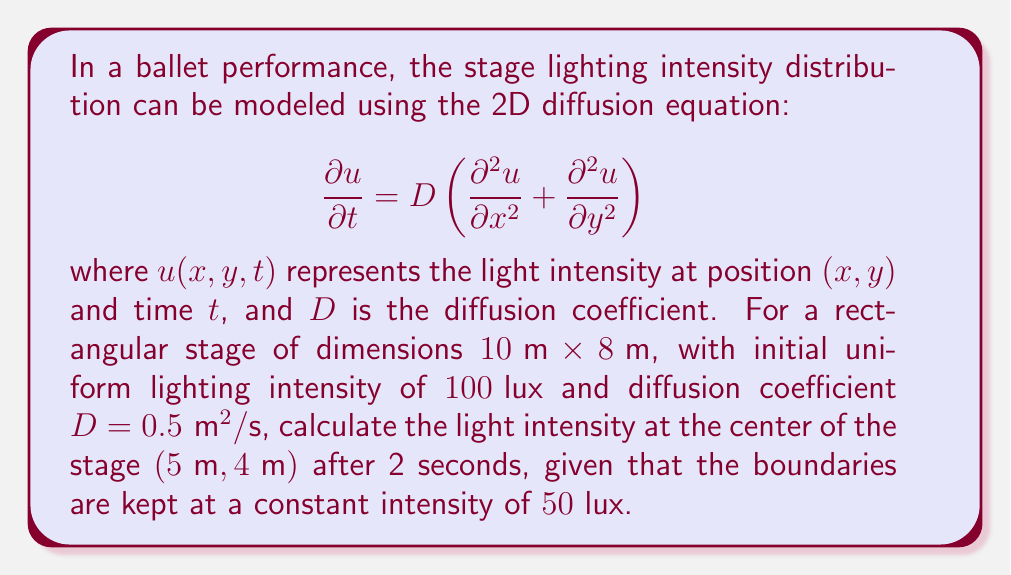Provide a solution to this math problem. To solve this problem, we need to use the analytical solution for the 2D diffusion equation with Dirichlet boundary conditions. The solution can be expressed as a double Fourier series:

$$u(x,y,t) = u_{\infty} + \sum_{m=1}^{\infty}\sum_{n=1}^{\infty} A_{mn} \sin\left(\frac{m\pi x}{L_x}\right)\sin\left(\frac{n\pi y}{L_y}\right)e^{-\lambda_{mn}t}$$

where:
- $u_{\infty}$ is the steady-state solution (boundary condition)
- $L_x = 10\text{ m}$ and $L_y = 8\text{ m}$ are the stage dimensions
- $\lambda_{mn} = D\pi^2\left(\frac{m^2}{L_x^2} + \frac{n^2}{L_y^2}\right)$
- $A_{mn}$ are the Fourier coefficients

For our initial condition $u_0(x,y) = 100\text{ lux}$ and boundary condition $u_{\infty} = 50\text{ lux}$, we can calculate $A_{mn}$:

$$A_{mn} = \frac{4}{L_xL_y}\int_0^{L_x}\int_0^{L_y} (u_0(x,y) - u_{\infty}) \sin\left(\frac{m\pi x}{L_x}\right)\sin\left(\frac{n\pi y}{L_y}\right) dx dy$$

$$A_{mn} = \frac{4(100-50)}{m n \pi^2} \left[1 - (-1)^m\right]\left[1 - (-1)^n\right]$$

Now, we can calculate the intensity at the center $(5\text{ m}, 4\text{ m})$ after 2 seconds:

$$u(5,4,2) = 50 + \sum_{m=1}^{\infty}\sum_{n=1}^{\infty} A_{mn} \sin\left(\frac{m\pi 5}{10}\right)\sin\left(\frac{n\pi 4}{8}\right)e^{-\lambda_{mn}2}$$

We'll truncate the series at $m=n=10$ for practical computation. Using a calculator or computer program to evaluate this sum, we get:

$$u(5,4,2) \approx 75.86\text{ lux}$$
Answer: The light intensity at the center of the stage $(5\text{ m}, 4\text{ m})$ after 2 seconds is approximately $75.86\text{ lux}$. 